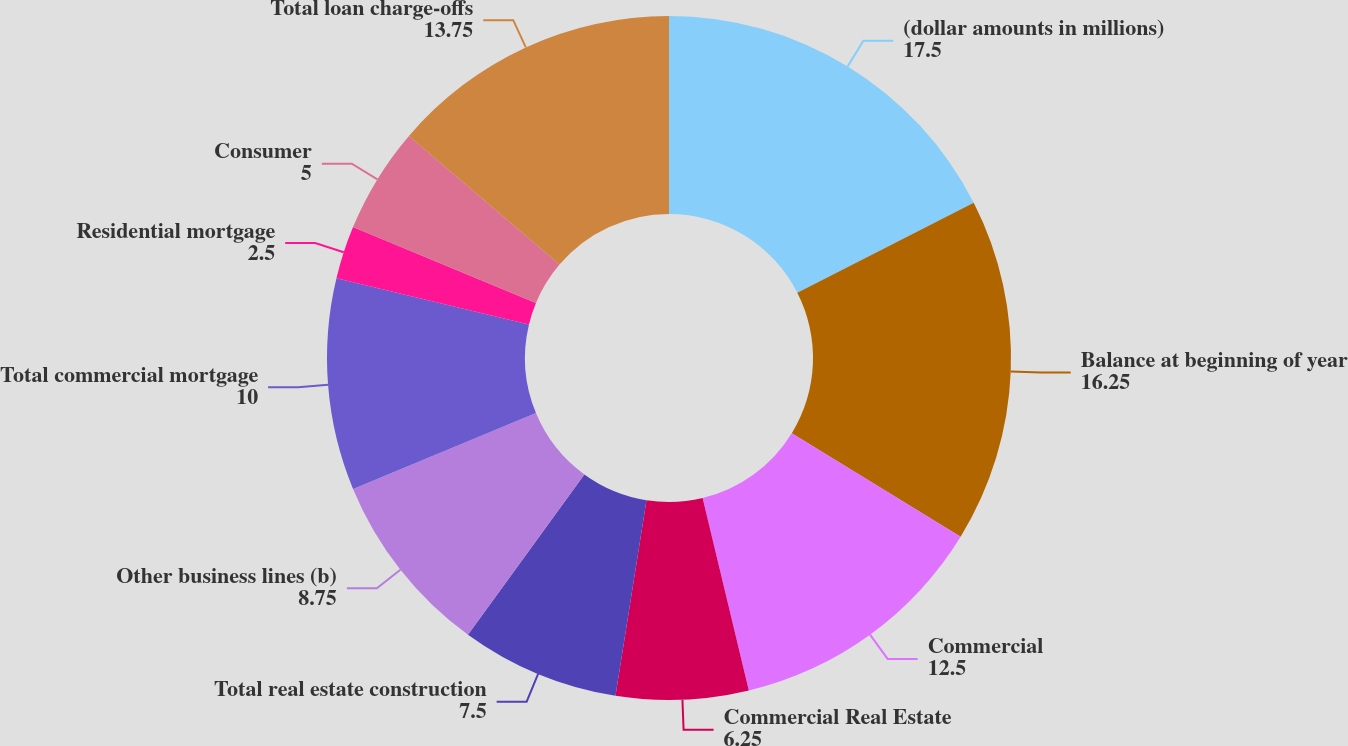<chart> <loc_0><loc_0><loc_500><loc_500><pie_chart><fcel>(dollar amounts in millions)<fcel>Balance at beginning of year<fcel>Commercial<fcel>Commercial Real Estate<fcel>Total real estate construction<fcel>Other business lines (b)<fcel>Total commercial mortgage<fcel>Residential mortgage<fcel>Consumer<fcel>Total loan charge-offs<nl><fcel>17.5%<fcel>16.25%<fcel>12.5%<fcel>6.25%<fcel>7.5%<fcel>8.75%<fcel>10.0%<fcel>2.5%<fcel>5.0%<fcel>13.75%<nl></chart> 